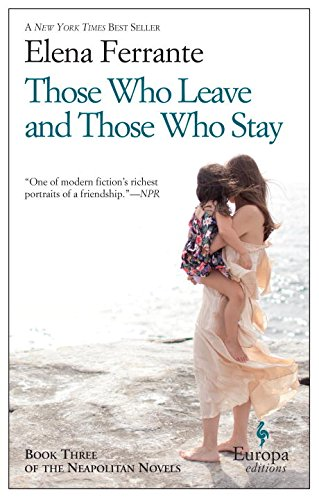What type of book is this? This book is categorized under Literature & Fiction, specifically portraying a rich narrative that delves into the complexities of personal and societal changes through detailed character development. 